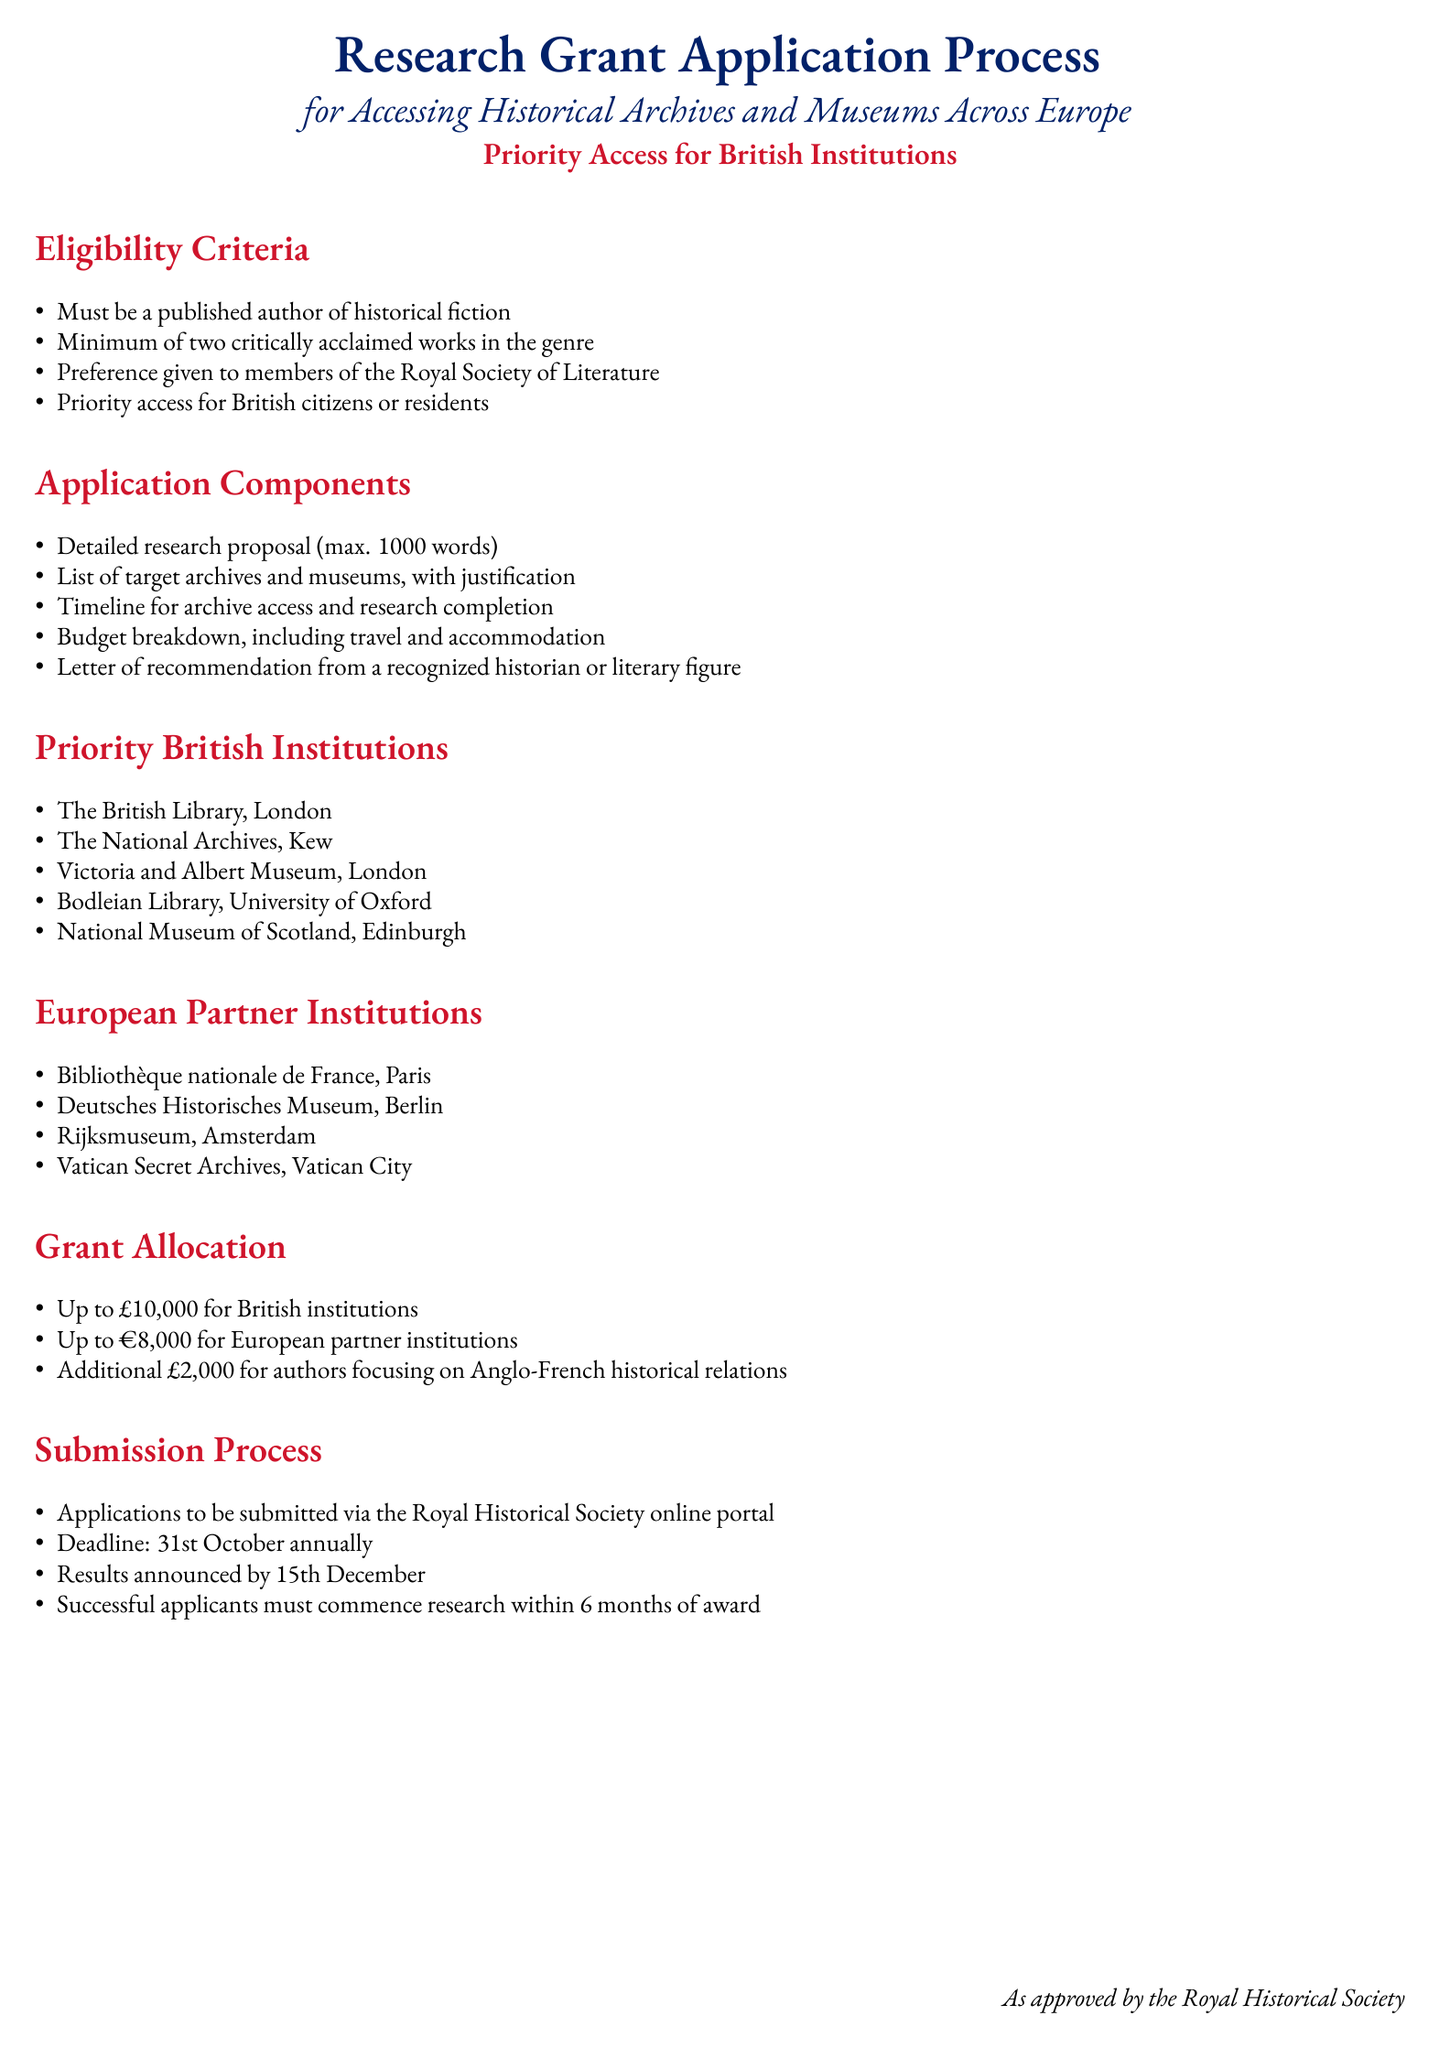What is the maximum budget for British institutions? The budget specified for British institutions in the document is £10,000.
Answer: £10,000 Who can provide a letter of recommendation? The document states that a letter of recommendation must be from a recognized historian or literary figure.
Answer: Recognized historian or literary figure What is the application deadline? The document mentions that applications must be submitted by the 31st of October annually.
Answer: 31st October Which institution is listed as the first priority British institution? The first institution listed under priority British institutions is The British Library, London.
Answer: The British Library, London How much additional funding is available for authors focusing on Anglo-French historical relations? According to the document, an additional £2,000 is designated for authors with this focus.
Answer: £2,000 What is the maximum research proposal length? The document specifies that the research proposal can be a maximum of 1000 words.
Answer: 1000 words When are results announced? The document details that the results of the application will be announced by the 15th of December.
Answer: 15th December What is the first component of the application? The first component listed in the application components is a detailed research proposal.
Answer: Detailed research proposal 